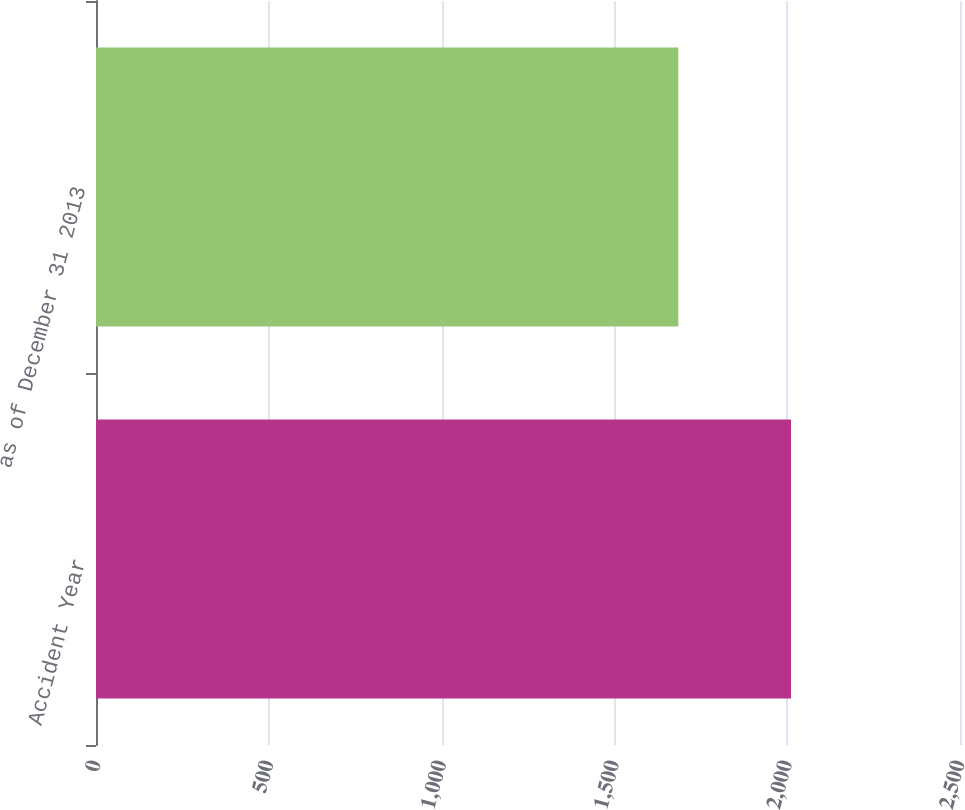Convert chart. <chart><loc_0><loc_0><loc_500><loc_500><bar_chart><fcel>Accident Year<fcel>as of December 31 2013<nl><fcel>2011<fcel>1685<nl></chart> 